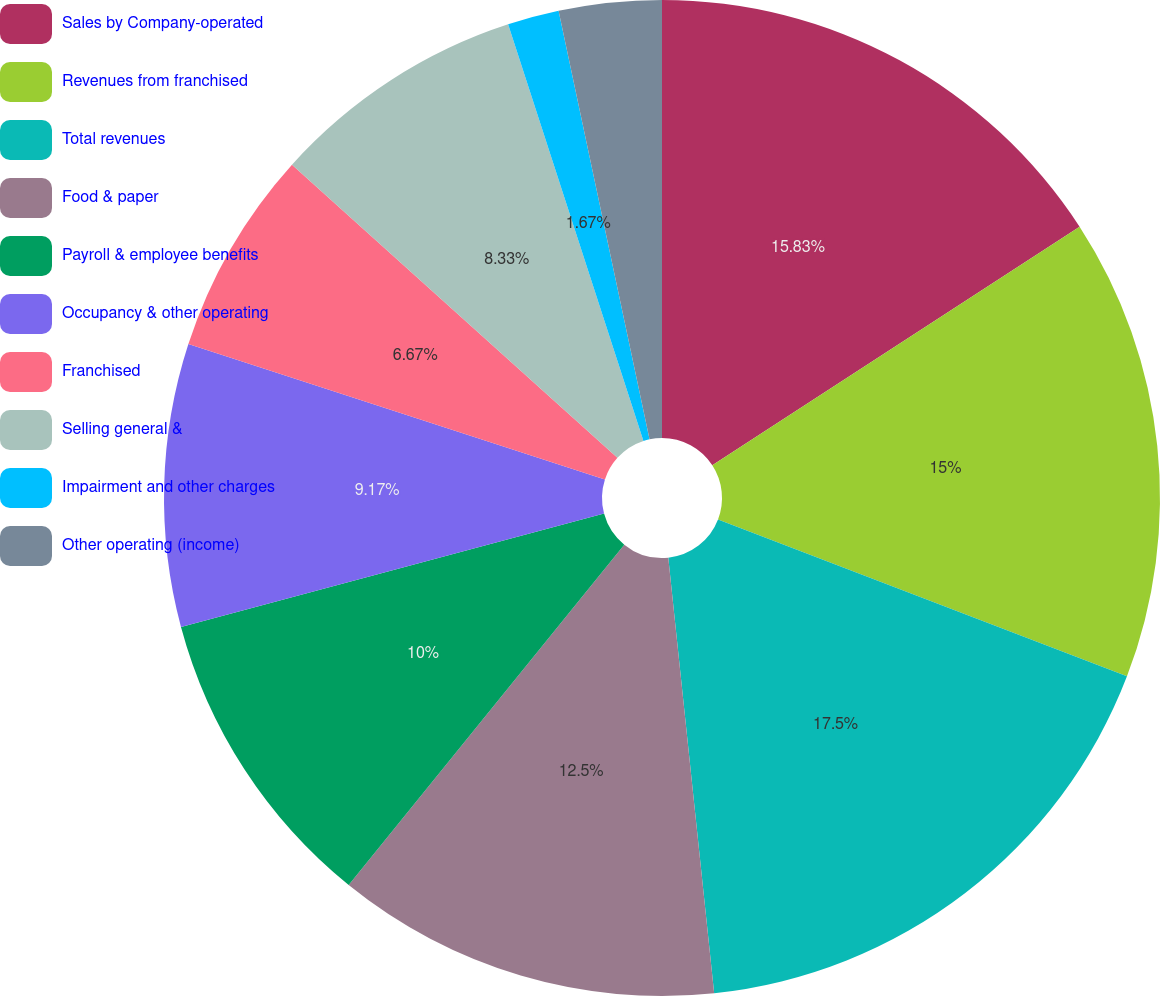Convert chart to OTSL. <chart><loc_0><loc_0><loc_500><loc_500><pie_chart><fcel>Sales by Company-operated<fcel>Revenues from franchised<fcel>Total revenues<fcel>Food & paper<fcel>Payroll & employee benefits<fcel>Occupancy & other operating<fcel>Franchised<fcel>Selling general &<fcel>Impairment and other charges<fcel>Other operating (income)<nl><fcel>15.83%<fcel>15.0%<fcel>17.5%<fcel>12.5%<fcel>10.0%<fcel>9.17%<fcel>6.67%<fcel>8.33%<fcel>1.67%<fcel>3.33%<nl></chart> 